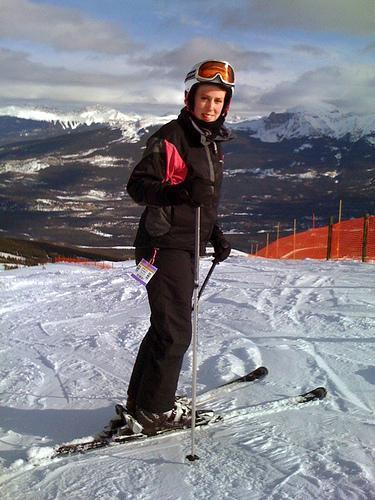How many mountains are in the background?
Give a very brief answer. 2. How many televisions are on?
Give a very brief answer. 0. 